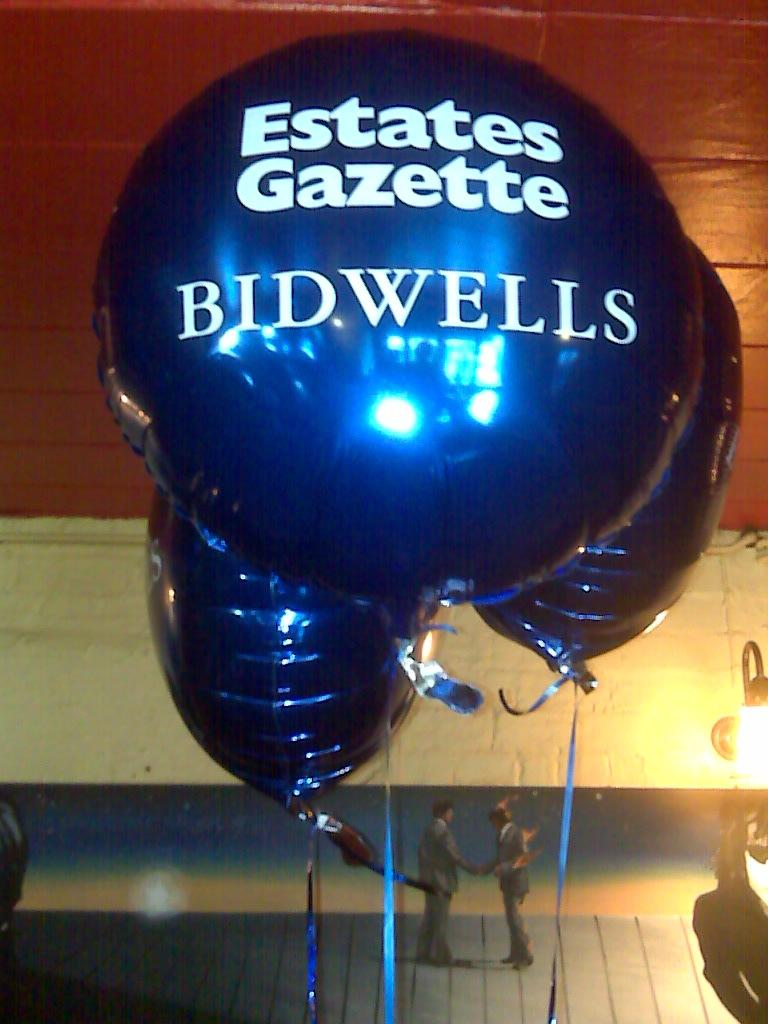What is written on the balloons in the image? There are text on the balloons in the image. Who or what is located at the bottom of the image? There are people at the bottom of the image. Can you describe the light source on the right side of the image? There is a light on the right side of the image. What color is the sister's scarf in the image? There is no mention of a sister or a scarf in the image, so we cannot answer that question. 